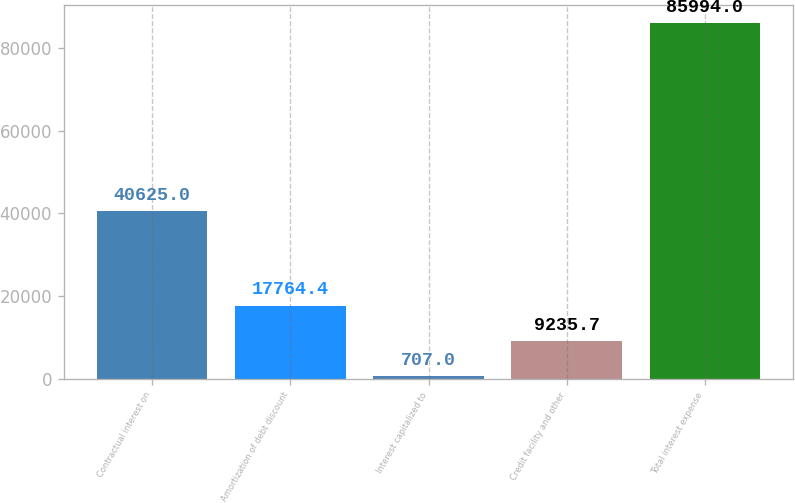Convert chart to OTSL. <chart><loc_0><loc_0><loc_500><loc_500><bar_chart><fcel>Contractual interest on<fcel>Amortization of debt discount<fcel>Interest capitalized to<fcel>Credit facility and other<fcel>Total interest expense<nl><fcel>40625<fcel>17764.4<fcel>707<fcel>9235.7<fcel>85994<nl></chart> 